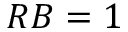<formula> <loc_0><loc_0><loc_500><loc_500>R B = 1</formula> 